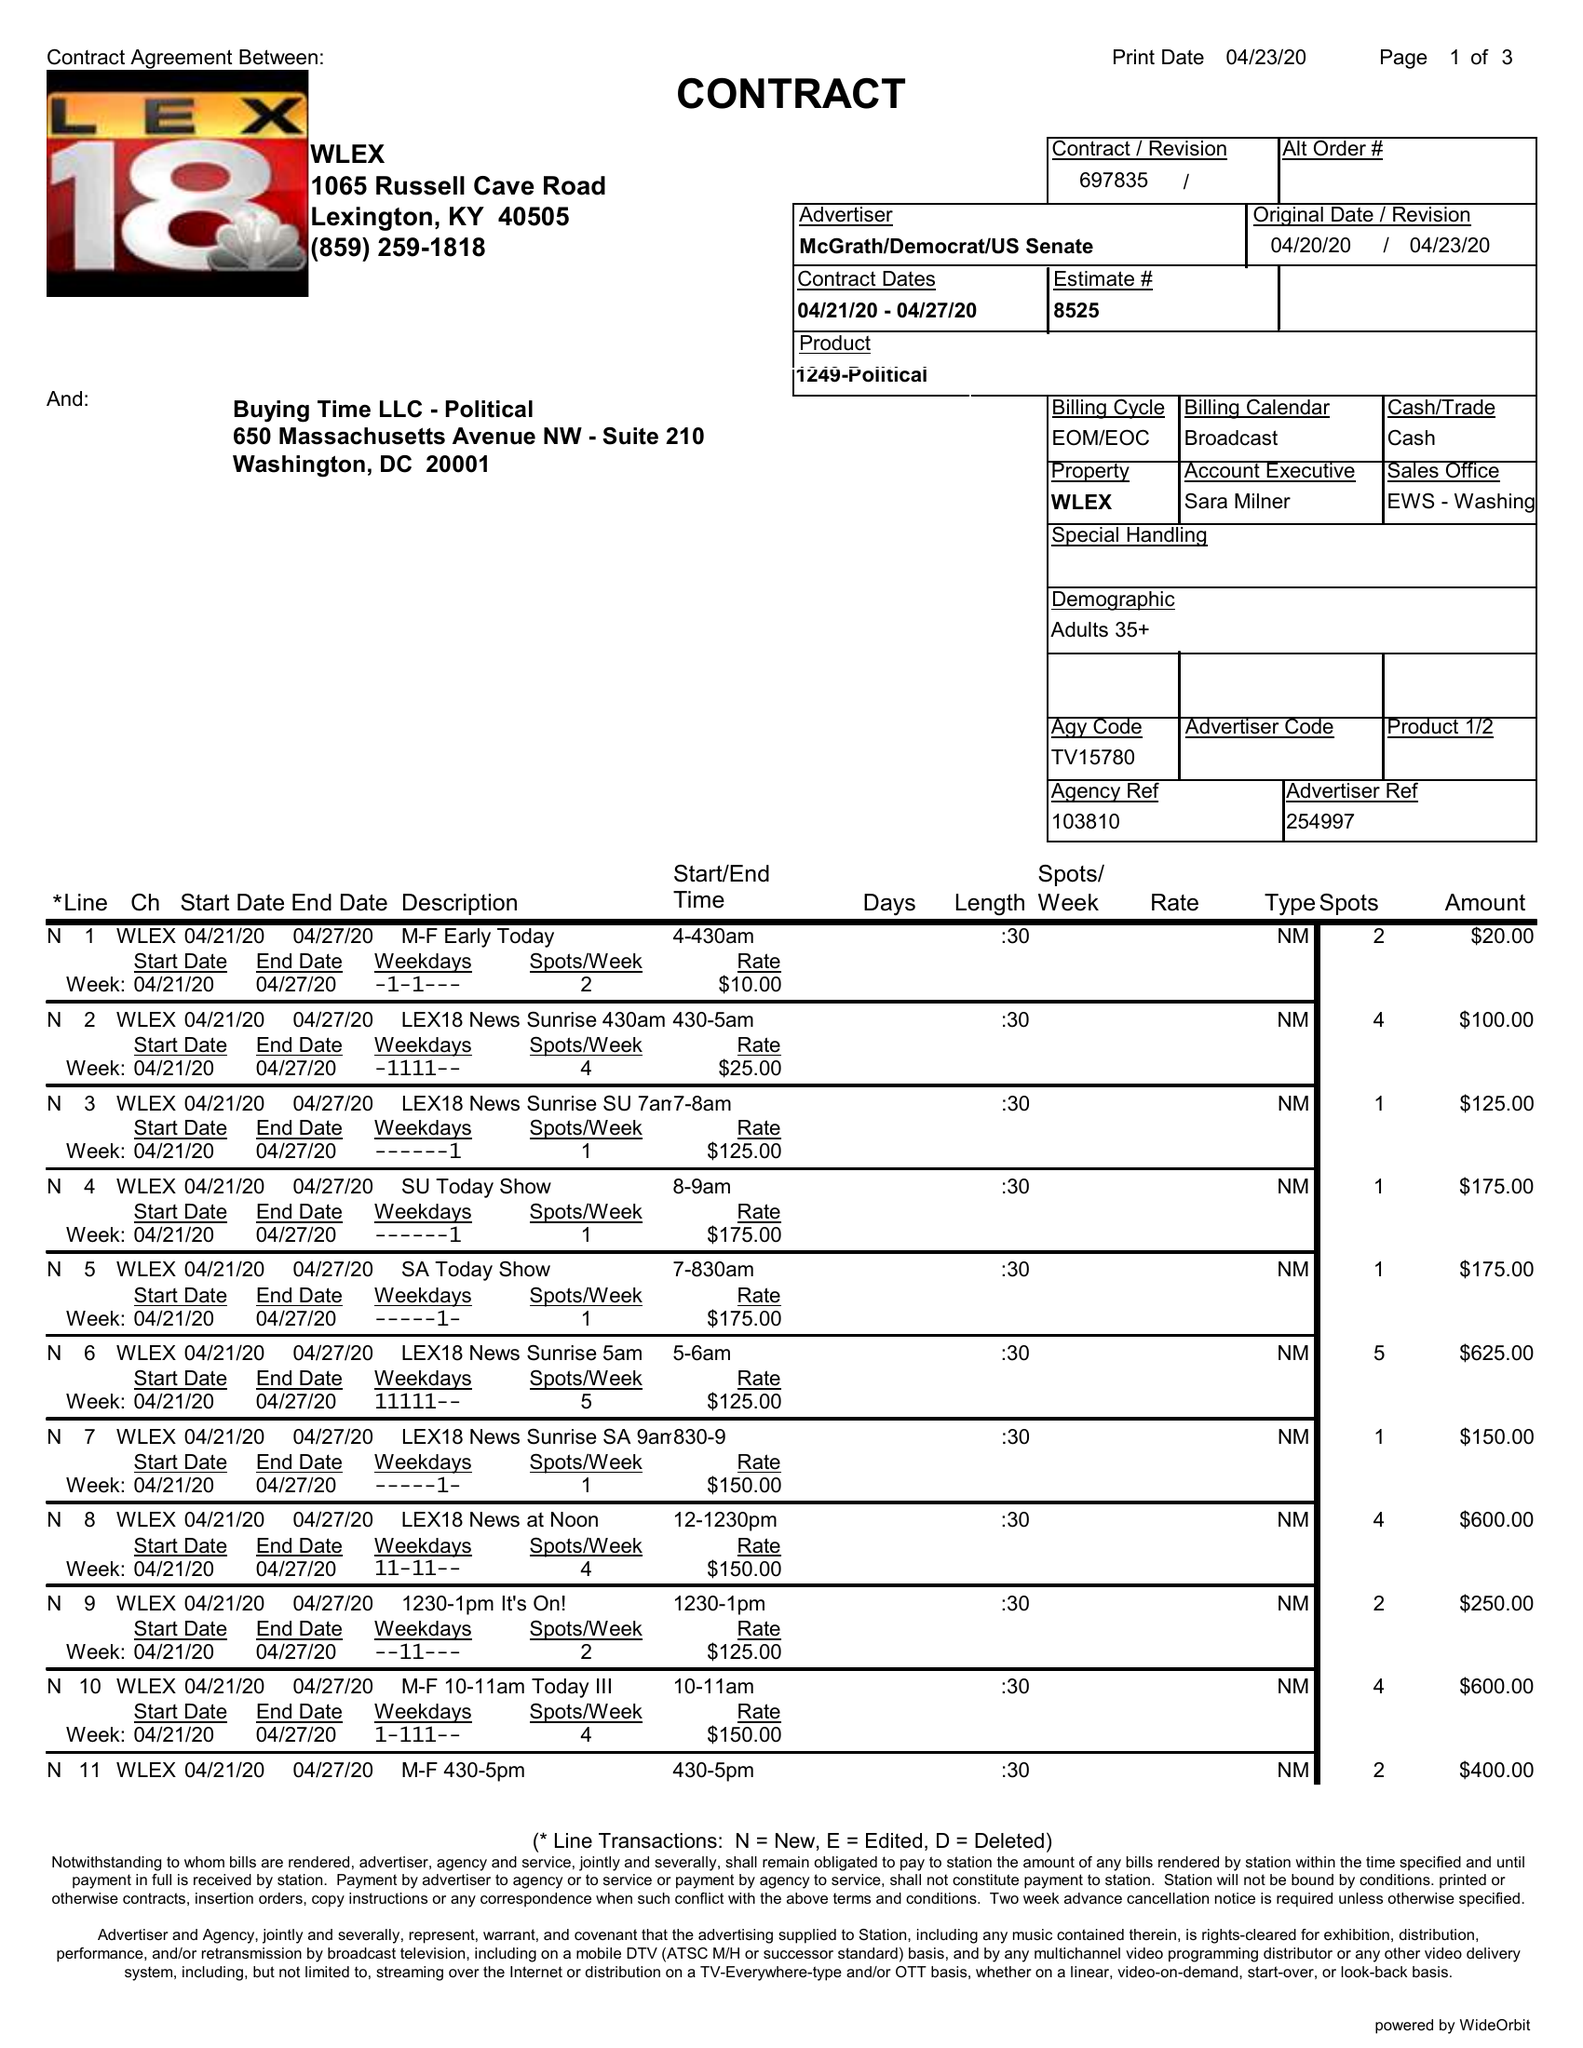What is the value for the flight_from?
Answer the question using a single word or phrase. 04/21/20 